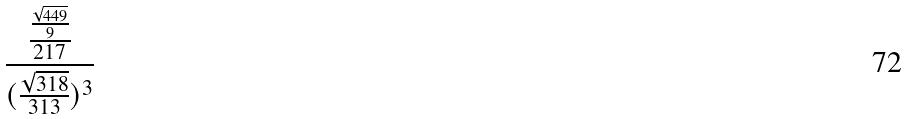Convert formula to latex. <formula><loc_0><loc_0><loc_500><loc_500>\frac { \frac { \frac { \sqrt { 4 4 9 } } { 9 } } { 2 1 7 } } { ( \frac { \sqrt { 3 1 8 } } { 3 1 3 } ) ^ { 3 } }</formula> 